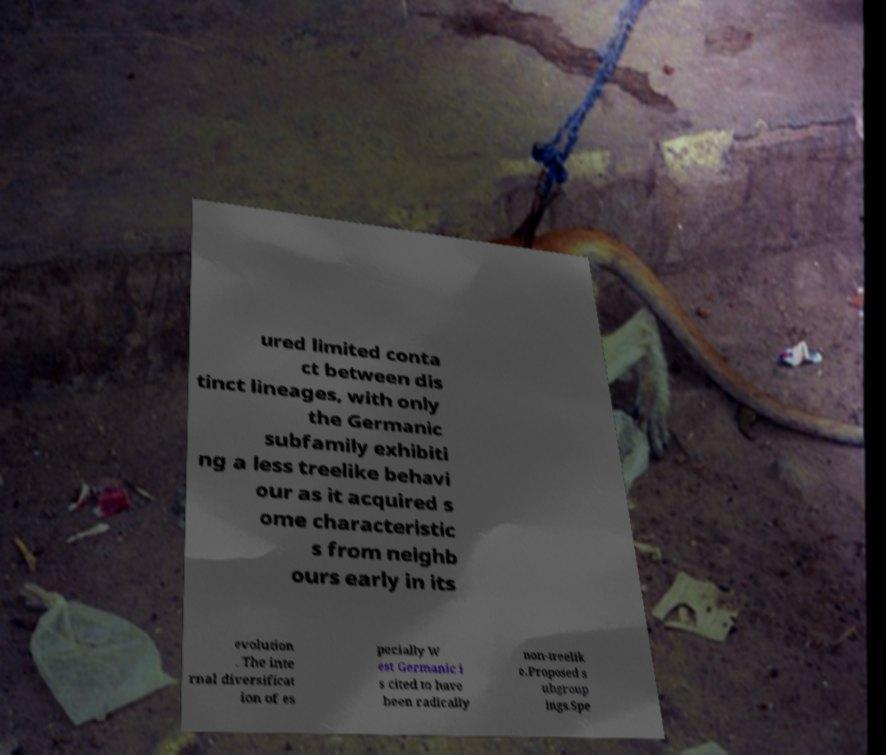Please identify and transcribe the text found in this image. ured limited conta ct between dis tinct lineages, with only the Germanic subfamily exhibiti ng a less treelike behavi our as it acquired s ome characteristic s from neighb ours early in its evolution . The inte rnal diversificat ion of es pecially W est Germanic i s cited to have been radically non-treelik e.Proposed s ubgroup ings.Spe 